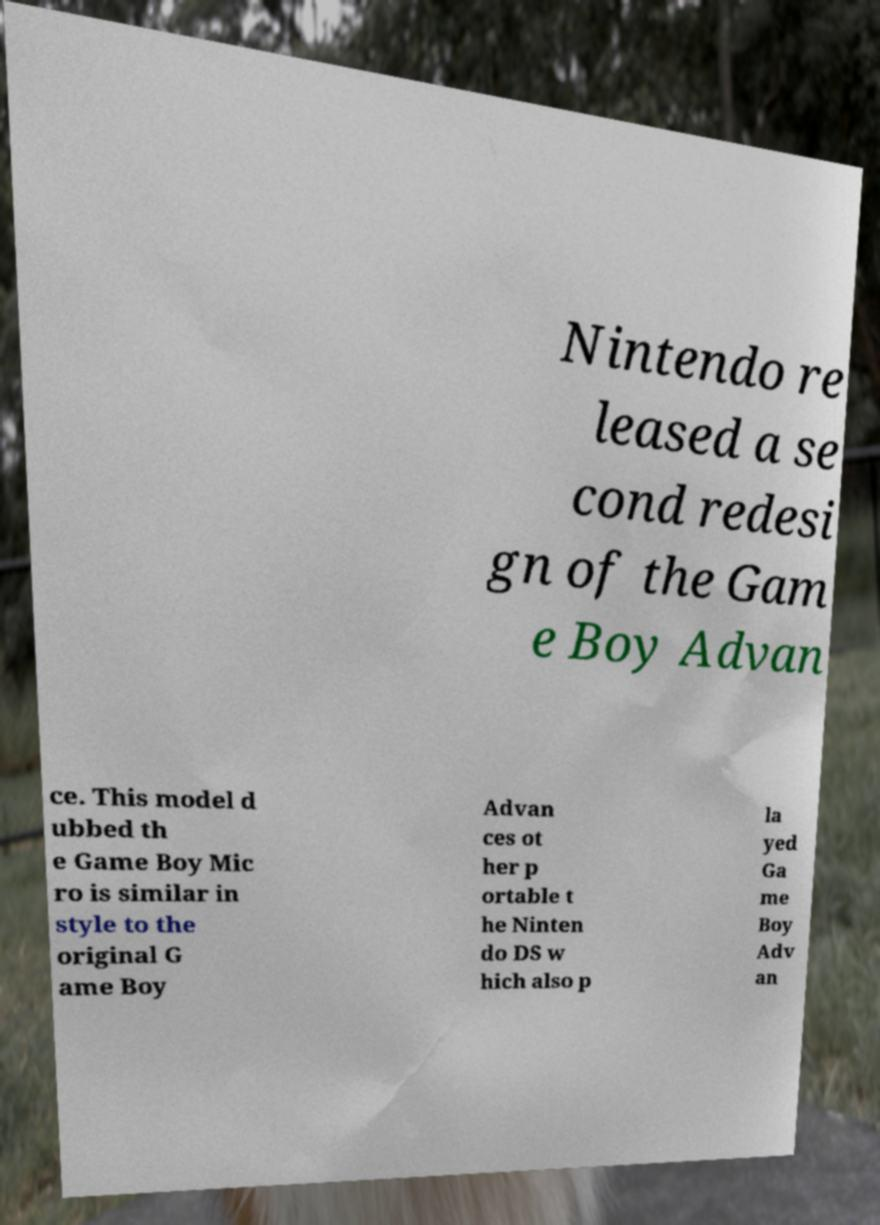Please read and relay the text visible in this image. What does it say? Nintendo re leased a se cond redesi gn of the Gam e Boy Advan ce. This model d ubbed th e Game Boy Mic ro is similar in style to the original G ame Boy Advan ces ot her p ortable t he Ninten do DS w hich also p la yed Ga me Boy Adv an 